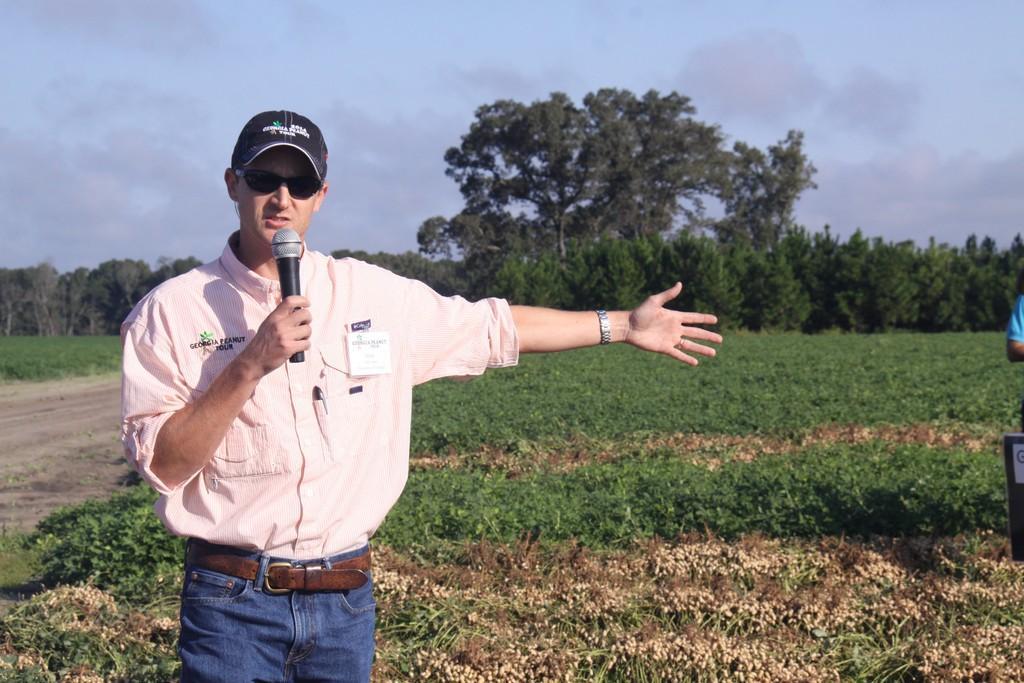Can you describe this image briefly? In this picture we can see a person holding a microphone in his hand. We can see another person and an object on the right side. There are some plants and a few trees in the background. Sky is cloudy. 